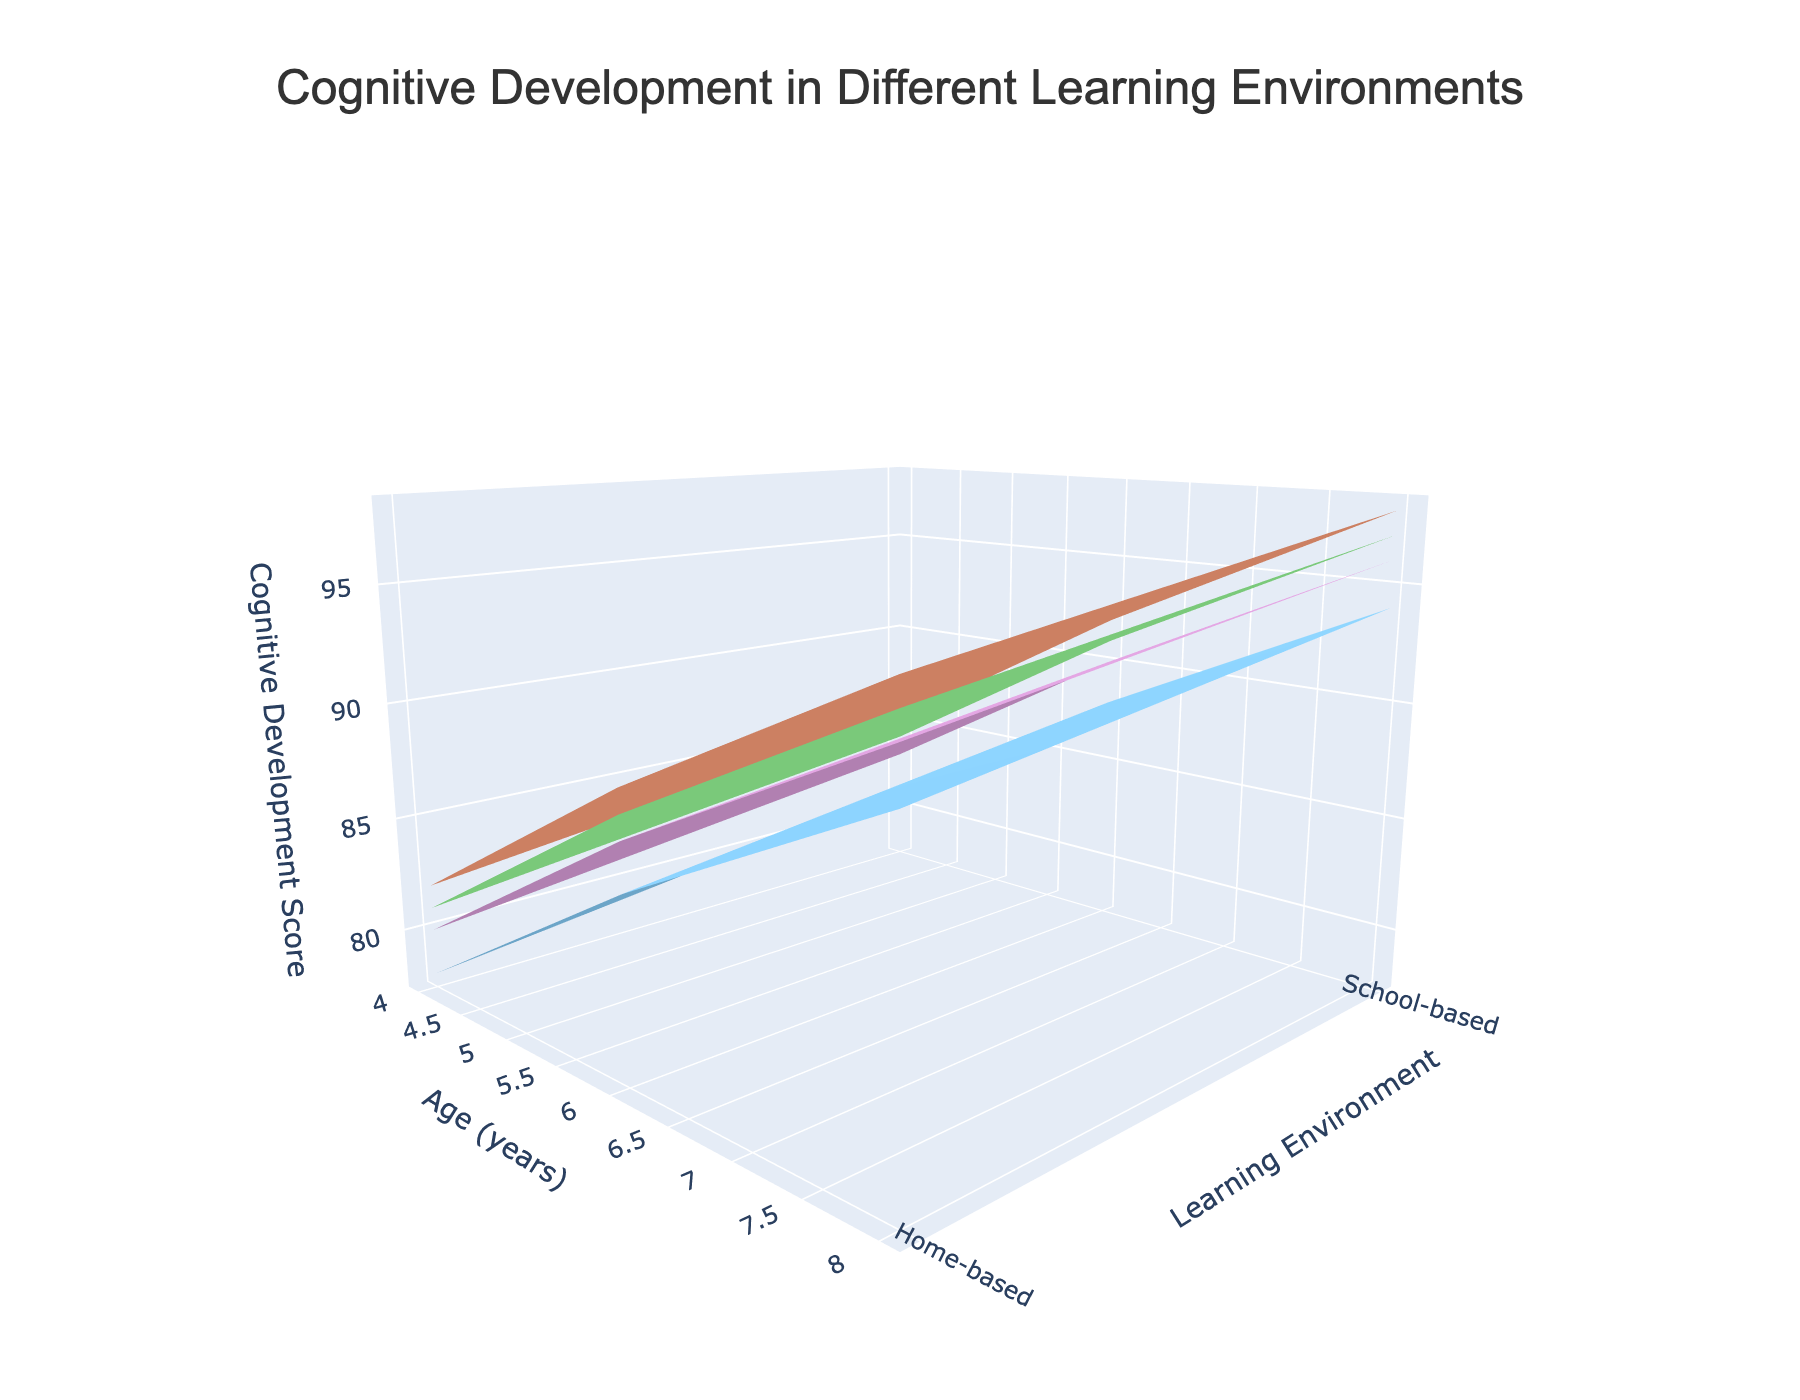What's the title of the plot? The title of the plot is usually displayed at the top of the figure and provides an overall description of what the plot is about. In this case, the title is: Cognitive Development in Different Learning Environments
Answer: Cognitive Development in Different Learning Environments What does the z-axis represent? The z-axis typically shows the value that varies across the conditions specified on the x and y axes. In this plot, the z-axis represents the Cognitive Development Score
Answer: Cognitive Development Score Which age group shows a higher cognitive development score in a school-based Montessori environment? To determine this, we look at the surface plot for the Montessori teaching style, specifically where the learning environment is school-based, and compare the scores for each age group. The highest score will be at age 8.
Answer: 8 years How do cognitive development scores compare between home-based and school-based learning environments for 4-year-olds using a Waldorf teaching style? To compare, locate the section of the plot representing the Waldorf style. Then, find and compare the scores for the 4-year-old group in both home-based and school-based environments. Scores show a higher value for school-based learning.
Answer: Higher in school-based What is the difference in cognitive development scores between 6-year-olds in Reggio Emilia home-based and school-based environments? Identify the surface plot section corresponding to the Reggio Emilia teaching style and compare the scores for 6-year-olds in both home-based and school-based environments. The gap is 91 - 88 = 3 points.
Answer: 3 points Which teaching style shows the least improvement in cognitive development from age 4 to age 8 in a home-based environment? Examine the change in scores for each teaching style in the home-based environment from age 4 to 8. The traditional teaching style shows the least improvement (from 78 to 91, an increase of 13 points).
Answer: Traditional Which learning environment results in higher cognitive development scores for 6-year-olds under the Montessori teaching style? Observe the cognitive development scores of 6-year-olds under the Montessori style in both learning environments. The school-based environment has higher scores.
Answer: School-based What trend do you observe in cognitive development scores with increasing age across all teaching styles in school-based environments? By examining the surface plot, it's clear that cognitive development scores consistently increase with age across all teaching styles in school-based environments.
Answer: Increasing For 4-year-olds, which teaching style appears to result in the lowest cognitive development scores in home-based environments? To find this, compare the scores of 4-year-olds across all teaching styles in home-based environments. The Traditional teaching style has the lowest score.
Answer: Traditional Which teaching style has the highest cognitive development score for 8-year-olds in school-based environments? Look at the scores for 8-year-olds in the school-based environments for each teaching style. The highest score is observed for the Montessori style.
Answer: Montessori 